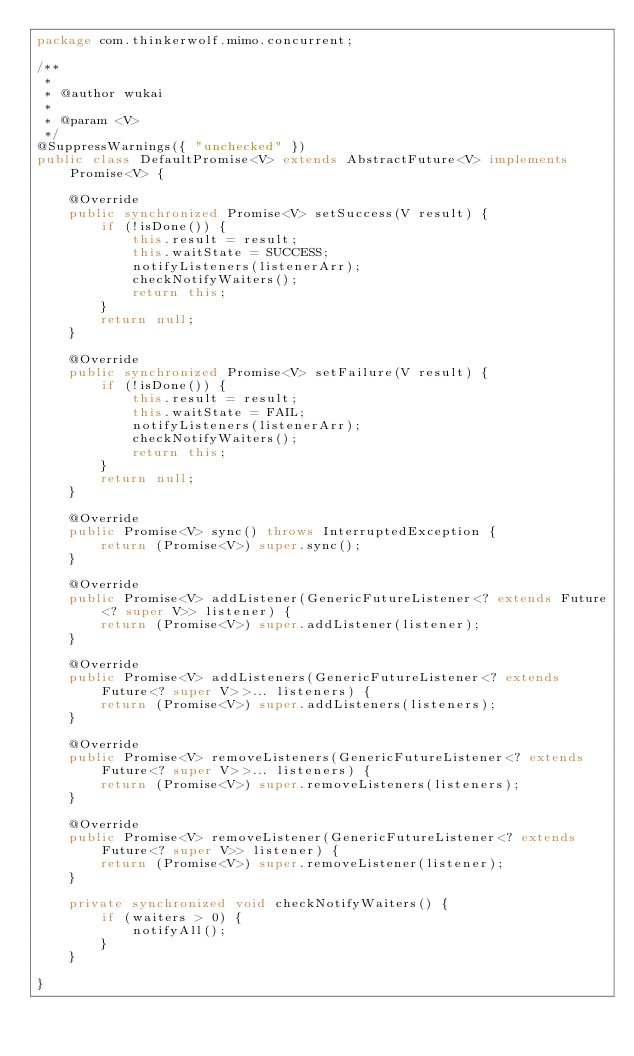<code> <loc_0><loc_0><loc_500><loc_500><_Java_>package com.thinkerwolf.mimo.concurrent;

/**
 * 
 * @author wukai
 *
 * @param <V>
 */
@SuppressWarnings({ "unchecked" })
public class DefaultPromise<V> extends AbstractFuture<V> implements Promise<V> {

	@Override
	public synchronized Promise<V> setSuccess(V result) {
		if (!isDone()) {
			this.result = result;
			this.waitState = SUCCESS;
			notifyListeners(listenerArr);
			checkNotifyWaiters();
			return this;
		}
		return null;
	}

	@Override
	public synchronized Promise<V> setFailure(V result) {
		if (!isDone()) {
			this.result = result;
			this.waitState = FAIL;
			notifyListeners(listenerArr);
			checkNotifyWaiters();
			return this;
		}
		return null;
	}

	@Override
	public Promise<V> sync() throws InterruptedException {
		return (Promise<V>) super.sync();
	}

	@Override
	public Promise<V> addListener(GenericFutureListener<? extends Future<? super V>> listener) {
		return (Promise<V>) super.addListener(listener);
	}

	@Override
	public Promise<V> addListeners(GenericFutureListener<? extends Future<? super V>>... listeners) {
		return (Promise<V>) super.addListeners(listeners);
	}

	@Override
	public Promise<V> removeListeners(GenericFutureListener<? extends Future<? super V>>... listeners) {
		return (Promise<V>) super.removeListeners(listeners);
	}

	@Override
	public Promise<V> removeListener(GenericFutureListener<? extends Future<? super V>> listener) {
		return (Promise<V>) super.removeListener(listener);
	}

	private synchronized void checkNotifyWaiters() {
		if (waiters > 0) {
			notifyAll();
		}
	}

}
</code> 